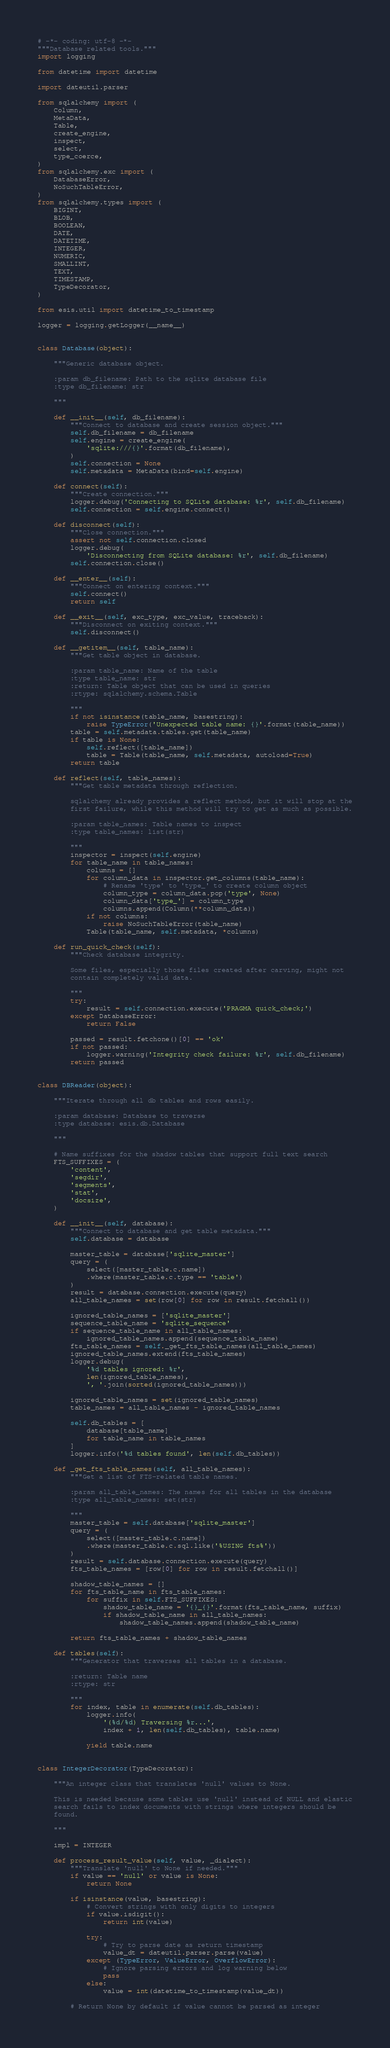Convert code to text. <code><loc_0><loc_0><loc_500><loc_500><_Python_># -*- coding: utf-8 -*-
"""Database related tools."""
import logging

from datetime import datetime

import dateutil.parser

from sqlalchemy import (
    Column,
    MetaData,
    Table,
    create_engine,
    inspect,
    select,
    type_coerce,
)
from sqlalchemy.exc import (
    DatabaseError,
    NoSuchTableError,
)
from sqlalchemy.types import (
    BIGINT,
    BLOB,
    BOOLEAN,
    DATE,
    DATETIME,
    INTEGER,
    NUMERIC,
    SMALLINT,
    TEXT,
    TIMESTAMP,
    TypeDecorator,
)

from esis.util import datetime_to_timestamp

logger = logging.getLogger(__name__)


class Database(object):

    """Generic database object.

    :param db_filename: Path to the sqlite database file
    :type db_filename: str

    """

    def __init__(self, db_filename):
        """Connect to database and create session object."""
        self.db_filename = db_filename
        self.engine = create_engine(
            'sqlite:///{}'.format(db_filename),
        )
        self.connection = None
        self.metadata = MetaData(bind=self.engine)

    def connect(self):
        """Create connection."""
        logger.debug('Connecting to SQLite database: %r', self.db_filename)
        self.connection = self.engine.connect()

    def disconnect(self):
        """Close connection."""
        assert not self.connection.closed
        logger.debug(
            'Disconnecting from SQLite database: %r', self.db_filename)
        self.connection.close()

    def __enter__(self):
        """Connect on entering context."""
        self.connect()
        return self

    def __exit__(self, exc_type, exc_value, traceback):
        """Disconnect on exiting context."""
        self.disconnect()

    def __getitem__(self, table_name):
        """Get table object in database.

        :param table_name: Name of the table
        :type table_name: str
        :return: Table object that can be used in queries
        :rtype: sqlalchemy.schema.Table

        """
        if not isinstance(table_name, basestring):
            raise TypeError('Unexpected table name: {}'.format(table_name))
        table = self.metadata.tables.get(table_name)
        if table is None:
            self.reflect([table_name])
            table = Table(table_name, self.metadata, autoload=True)
        return table

    def reflect(self, table_names):
        """Get table metadata through reflection.

        sqlalchemy already provides a reflect method, but it will stop at the
        first failure, while this method will try to get as much as possible.

        :param table_names: Table names to inspect
        :type table_names: list(str)

        """
        inspector = inspect(self.engine)
        for table_name in table_names:
            columns = []
            for column_data in inspector.get_columns(table_name):
                # Rename 'type' to 'type_' to create column object
                column_type = column_data.pop('type', None)
                column_data['type_'] = column_type
                columns.append(Column(**column_data))
            if not columns:
                raise NoSuchTableError(table_name)
            Table(table_name, self.metadata, *columns)

    def run_quick_check(self):
        """Check database integrity.

        Some files, especially those files created after carving, might not
        contain completely valid data.

        """
        try:
            result = self.connection.execute('PRAGMA quick_check;')
        except DatabaseError:
            return False

        passed = result.fetchone()[0] == 'ok'
        if not passed:
            logger.warning('Integrity check failure: %r', self.db_filename)
        return passed


class DBReader(object):

    """Iterate through all db tables and rows easily.

    :param database: Database to traverse
    :type database: esis.db.Database

    """

    # Name suffixes for the shadow tables that support full text search
    FTS_SUFFIXES = (
        'content',
        'segdir',
        'segments',
        'stat',
        'docsize',
    )

    def __init__(self, database):
        """Connect to database and get table metadata."""
        self.database = database

        master_table = database['sqlite_master']
        query = (
            select([master_table.c.name])
            .where(master_table.c.type == 'table')
        )
        result = database.connection.execute(query)
        all_table_names = set(row[0] for row in result.fetchall())

        ignored_table_names = ['sqlite_master']
        sequence_table_name = 'sqlite_sequence'
        if sequence_table_name in all_table_names:
            ignored_table_names.append(sequence_table_name)
        fts_table_names = self._get_fts_table_names(all_table_names)
        ignored_table_names.extend(fts_table_names)
        logger.debug(
            '%d tables ignored: %r',
            len(ignored_table_names),
            ', '.join(sorted(ignored_table_names)))

        ignored_table_names = set(ignored_table_names)
        table_names = all_table_names - ignored_table_names

        self.db_tables = [
            database[table_name]
            for table_name in table_names
        ]
        logger.info('%d tables found', len(self.db_tables))

    def _get_fts_table_names(self, all_table_names):
        """Get a list of FTS-related table names.

        :param all_table_names: The names for all tables in the database
        :type all_table_names: set(str)

        """
        master_table = self.database['sqlite_master']
        query = (
            select([master_table.c.name])
            .where(master_table.c.sql.like('%USING fts%'))
        )
        result = self.database.connection.execute(query)
        fts_table_names = [row[0] for row in result.fetchall()]

        shadow_table_names = []
        for fts_table_name in fts_table_names:
            for suffix in self.FTS_SUFFIXES:
                shadow_table_name = '{}_{}'.format(fts_table_name, suffix)
                if shadow_table_name in all_table_names:
                    shadow_table_names.append(shadow_table_name)

        return fts_table_names + shadow_table_names

    def tables(self):
        """Generator that traverses all tables in a database.

        :return: Table name
        :rtype: str

        """
        for index, table in enumerate(self.db_tables):
            logger.info(
                '(%d/%d) Traversing %r...',
                index + 1, len(self.db_tables), table.name)

            yield table.name


class IntegerDecorator(TypeDecorator):

    """An integer class that translates 'null' values to None.

    This is needed because some tables use 'null' instead of NULL and elastic
    search fails to index documents with strings where integers should be
    found.

    """

    impl = INTEGER

    def process_result_value(self, value, _dialect):
        """Translate 'null' to None if needed."""
        if value == 'null' or value is None:
            return None

        if isinstance(value, basestring):
            # Convert strings with only digits to integers
            if value.isdigit():
                return int(value)

            try:
                # Try to parse date as return timestamp
                value_dt = dateutil.parser.parse(value)
            except (TypeError, ValueError, OverflowError):
                # Ignore parsing errors and log warning below
                pass
            else:
                value = int(datetime_to_timestamp(value_dt))

        # Return None by default if value cannot be parsed as integer</code> 